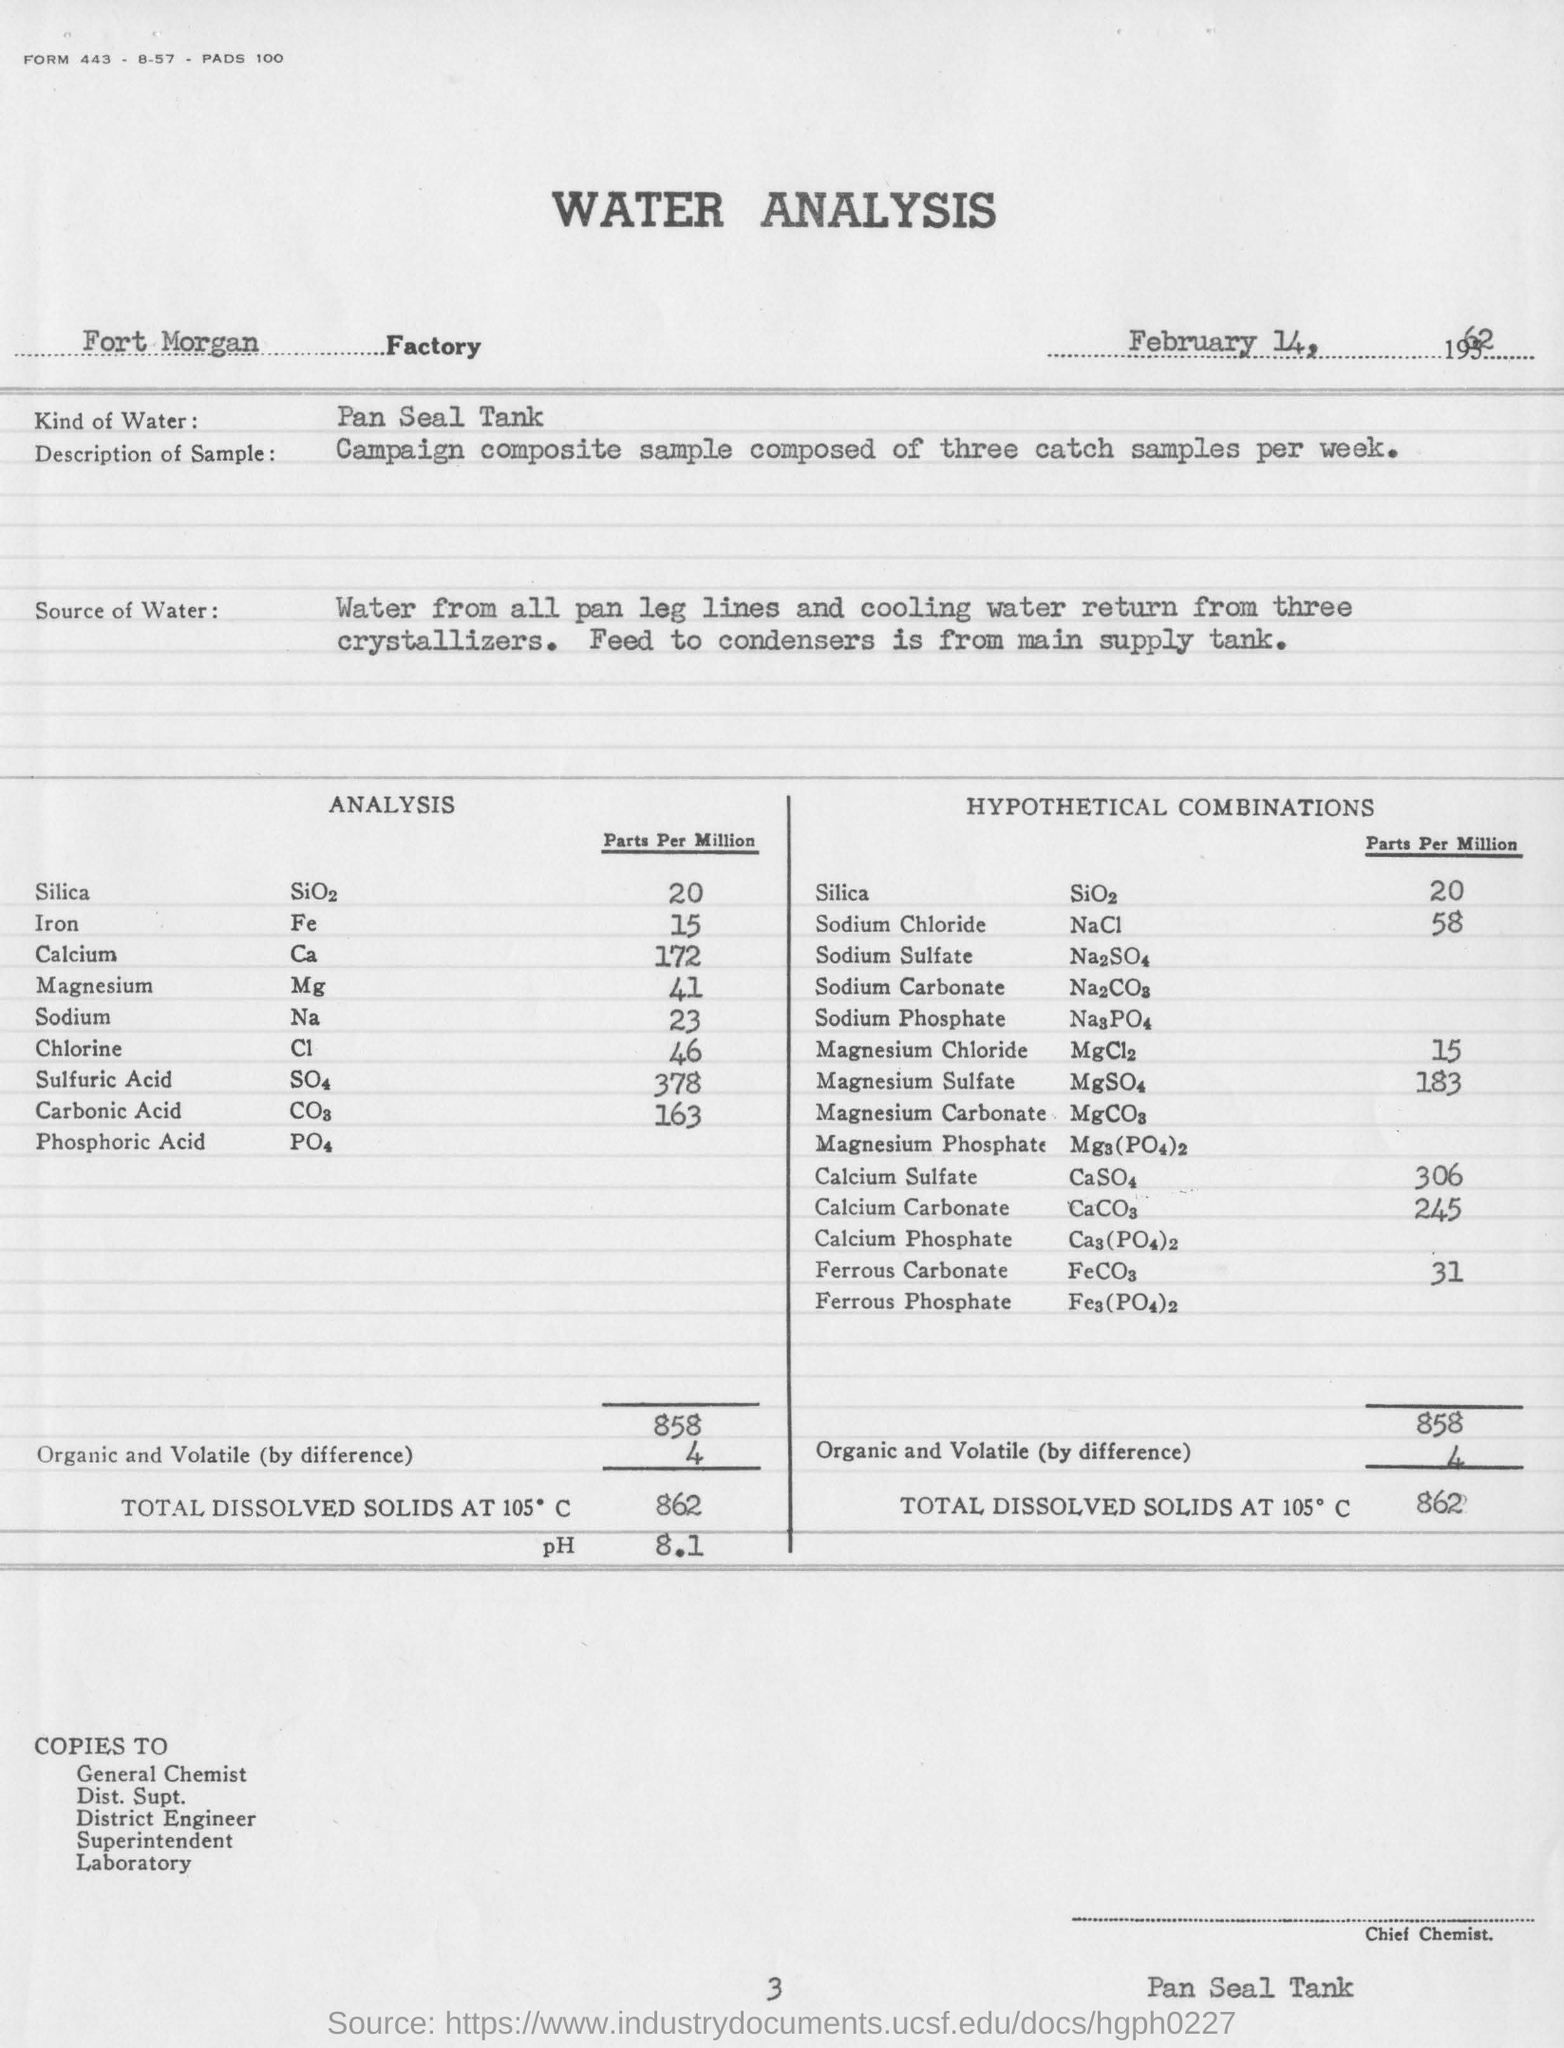Indicate a few pertinent items in this graphic. The analysis report indicates that the iron rate is 15... The pH value mentioned in the analysis is 8.1. 